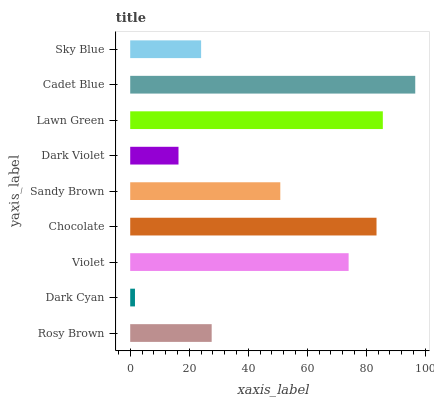Is Dark Cyan the minimum?
Answer yes or no. Yes. Is Cadet Blue the maximum?
Answer yes or no. Yes. Is Violet the minimum?
Answer yes or no. No. Is Violet the maximum?
Answer yes or no. No. Is Violet greater than Dark Cyan?
Answer yes or no. Yes. Is Dark Cyan less than Violet?
Answer yes or no. Yes. Is Dark Cyan greater than Violet?
Answer yes or no. No. Is Violet less than Dark Cyan?
Answer yes or no. No. Is Sandy Brown the high median?
Answer yes or no. Yes. Is Sandy Brown the low median?
Answer yes or no. Yes. Is Chocolate the high median?
Answer yes or no. No. Is Chocolate the low median?
Answer yes or no. No. 